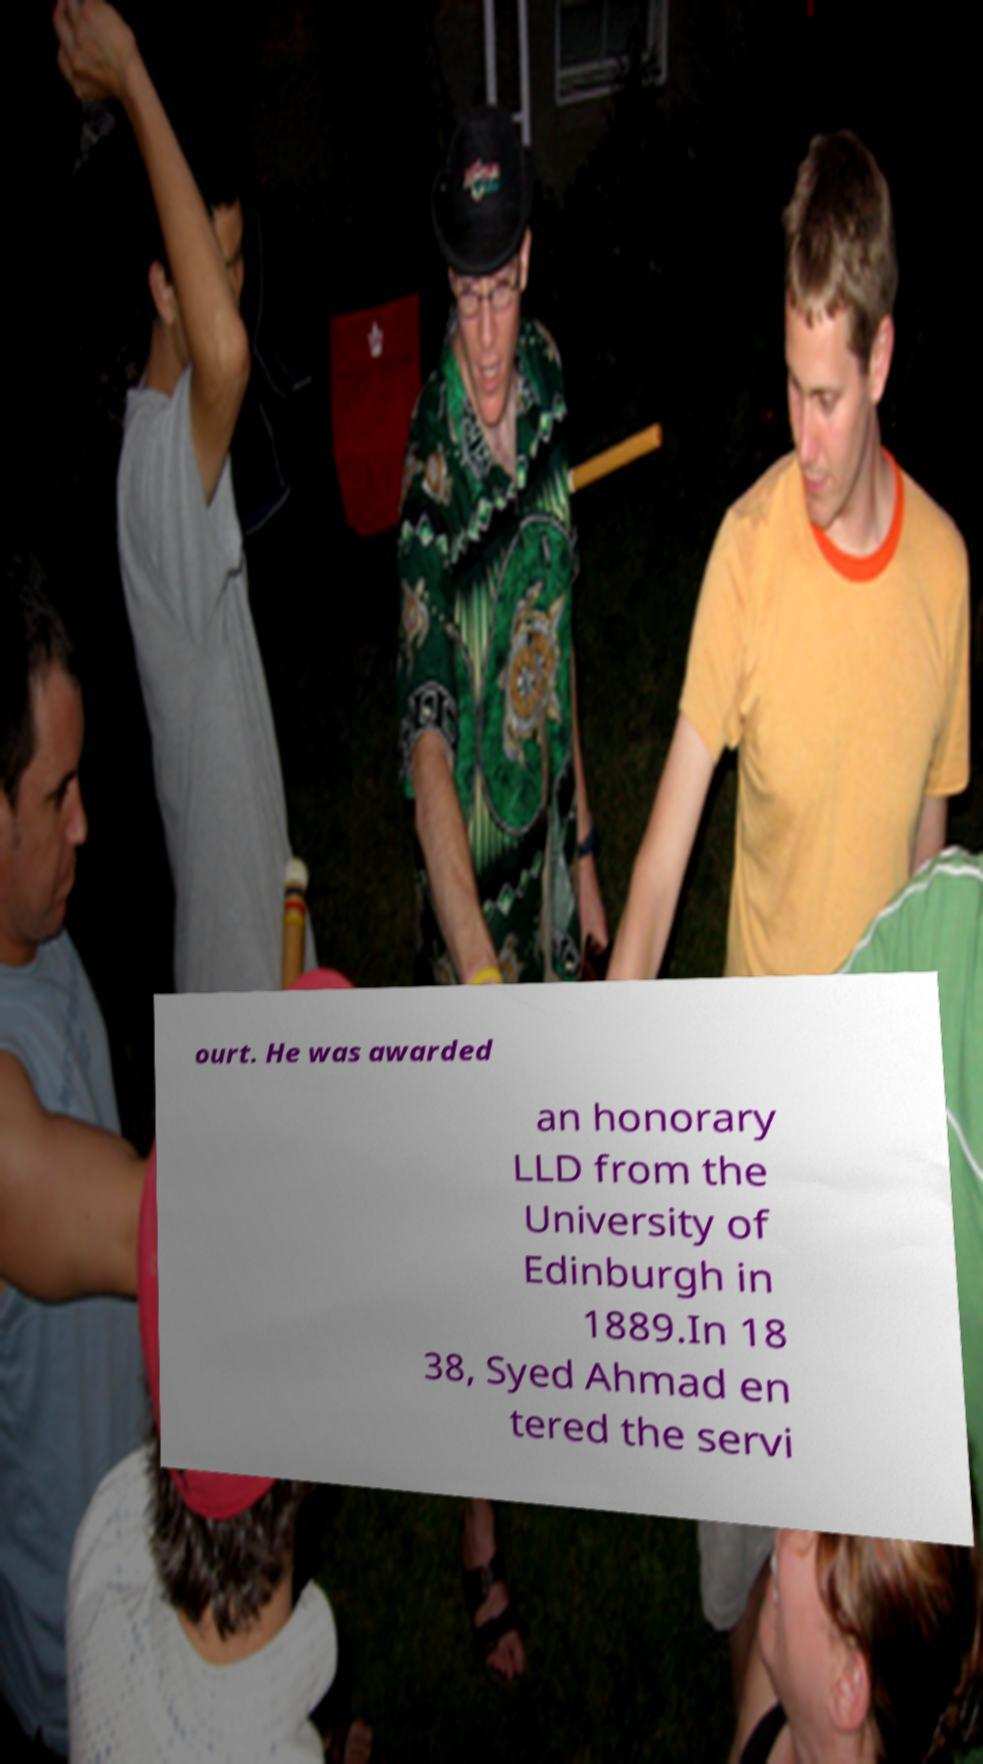Please read and relay the text visible in this image. What does it say? ourt. He was awarded an honorary LLD from the University of Edinburgh in 1889.In 18 38, Syed Ahmad en tered the servi 